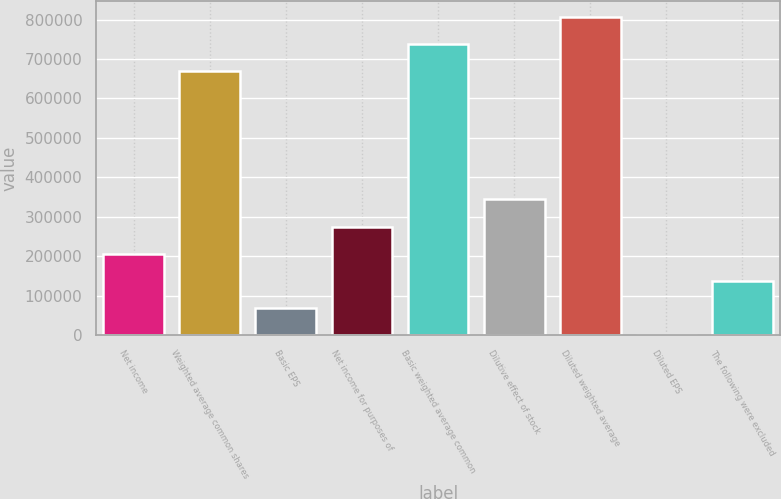<chart> <loc_0><loc_0><loc_500><loc_500><bar_chart><fcel>Net income<fcel>Weighted average common shares<fcel>Basic EPS<fcel>Net income for purposes of<fcel>Basic weighted average common<fcel>Dilutive effect of stock<fcel>Diluted weighted average<fcel>Diluted EPS<fcel>The following were excluded<nl><fcel>206214<fcel>668393<fcel>68745.5<fcel>274949<fcel>737127<fcel>343683<fcel>805862<fcel>11.07<fcel>137480<nl></chart> 